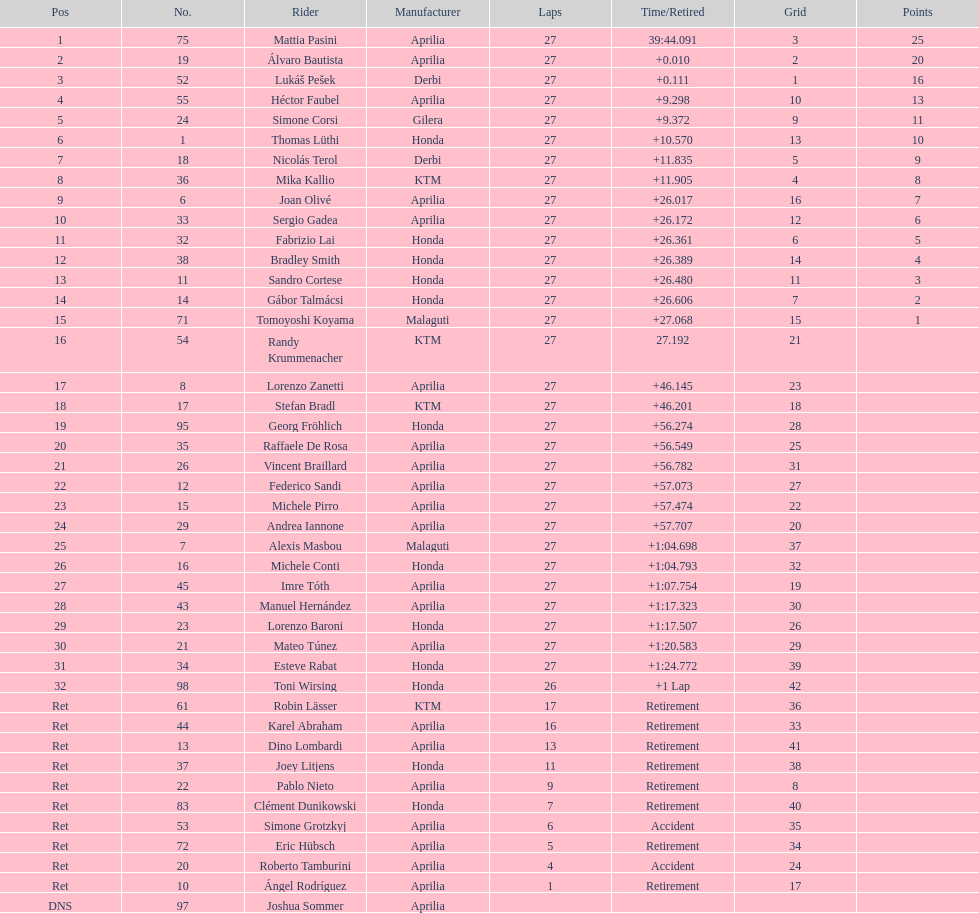What was the total number of positions in the 125cc classification? 43. 